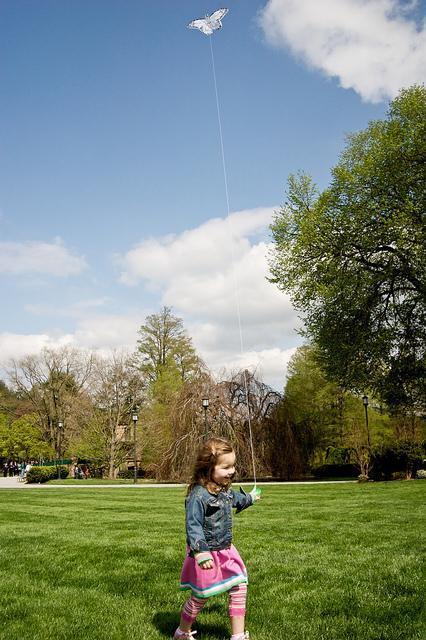How many children are visible?
Give a very brief answer. 1. How many people are there?
Give a very brief answer. 1. 